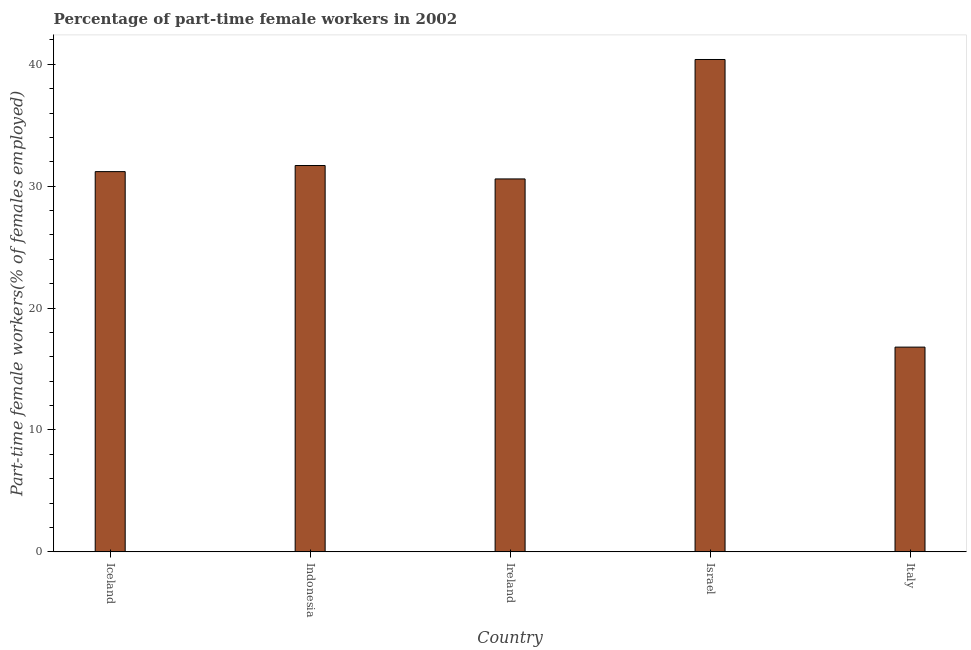What is the title of the graph?
Provide a succinct answer. Percentage of part-time female workers in 2002. What is the label or title of the X-axis?
Give a very brief answer. Country. What is the label or title of the Y-axis?
Your response must be concise. Part-time female workers(% of females employed). What is the percentage of part-time female workers in Iceland?
Your answer should be compact. 31.2. Across all countries, what is the maximum percentage of part-time female workers?
Ensure brevity in your answer.  40.4. Across all countries, what is the minimum percentage of part-time female workers?
Provide a short and direct response. 16.8. What is the sum of the percentage of part-time female workers?
Give a very brief answer. 150.7. What is the difference between the percentage of part-time female workers in Iceland and Ireland?
Offer a very short reply. 0.6. What is the average percentage of part-time female workers per country?
Offer a very short reply. 30.14. What is the median percentage of part-time female workers?
Your answer should be very brief. 31.2. In how many countries, is the percentage of part-time female workers greater than 12 %?
Provide a short and direct response. 5. What is the ratio of the percentage of part-time female workers in Ireland to that in Israel?
Your answer should be very brief. 0.76. Is the difference between the percentage of part-time female workers in Israel and Italy greater than the difference between any two countries?
Give a very brief answer. Yes. What is the difference between the highest and the second highest percentage of part-time female workers?
Offer a terse response. 8.7. What is the difference between the highest and the lowest percentage of part-time female workers?
Give a very brief answer. 23.6. How many bars are there?
Provide a succinct answer. 5. Are all the bars in the graph horizontal?
Ensure brevity in your answer.  No. How many countries are there in the graph?
Provide a succinct answer. 5. What is the Part-time female workers(% of females employed) of Iceland?
Your answer should be compact. 31.2. What is the Part-time female workers(% of females employed) of Indonesia?
Your answer should be very brief. 31.7. What is the Part-time female workers(% of females employed) of Ireland?
Make the answer very short. 30.6. What is the Part-time female workers(% of females employed) in Israel?
Your answer should be compact. 40.4. What is the Part-time female workers(% of females employed) of Italy?
Make the answer very short. 16.8. What is the difference between the Part-time female workers(% of females employed) in Iceland and Ireland?
Provide a succinct answer. 0.6. What is the difference between the Part-time female workers(% of females employed) in Iceland and Italy?
Make the answer very short. 14.4. What is the difference between the Part-time female workers(% of females employed) in Ireland and Italy?
Keep it short and to the point. 13.8. What is the difference between the Part-time female workers(% of females employed) in Israel and Italy?
Ensure brevity in your answer.  23.6. What is the ratio of the Part-time female workers(% of females employed) in Iceland to that in Ireland?
Your answer should be very brief. 1.02. What is the ratio of the Part-time female workers(% of females employed) in Iceland to that in Israel?
Ensure brevity in your answer.  0.77. What is the ratio of the Part-time female workers(% of females employed) in Iceland to that in Italy?
Ensure brevity in your answer.  1.86. What is the ratio of the Part-time female workers(% of females employed) in Indonesia to that in Ireland?
Your answer should be very brief. 1.04. What is the ratio of the Part-time female workers(% of females employed) in Indonesia to that in Israel?
Your response must be concise. 0.79. What is the ratio of the Part-time female workers(% of females employed) in Indonesia to that in Italy?
Your response must be concise. 1.89. What is the ratio of the Part-time female workers(% of females employed) in Ireland to that in Israel?
Offer a terse response. 0.76. What is the ratio of the Part-time female workers(% of females employed) in Ireland to that in Italy?
Provide a short and direct response. 1.82. What is the ratio of the Part-time female workers(% of females employed) in Israel to that in Italy?
Offer a terse response. 2.4. 